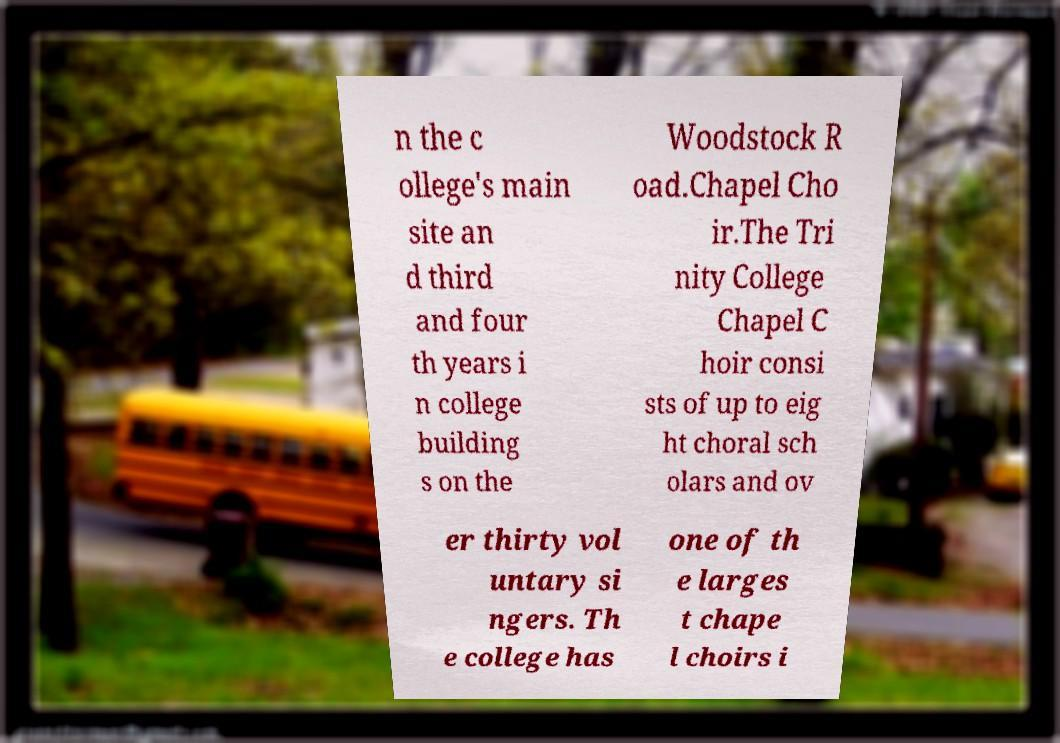Could you assist in decoding the text presented in this image and type it out clearly? n the c ollege's main site an d third and four th years i n college building s on the Woodstock R oad.Chapel Cho ir.The Tri nity College Chapel C hoir consi sts of up to eig ht choral sch olars and ov er thirty vol untary si ngers. Th e college has one of th e larges t chape l choirs i 